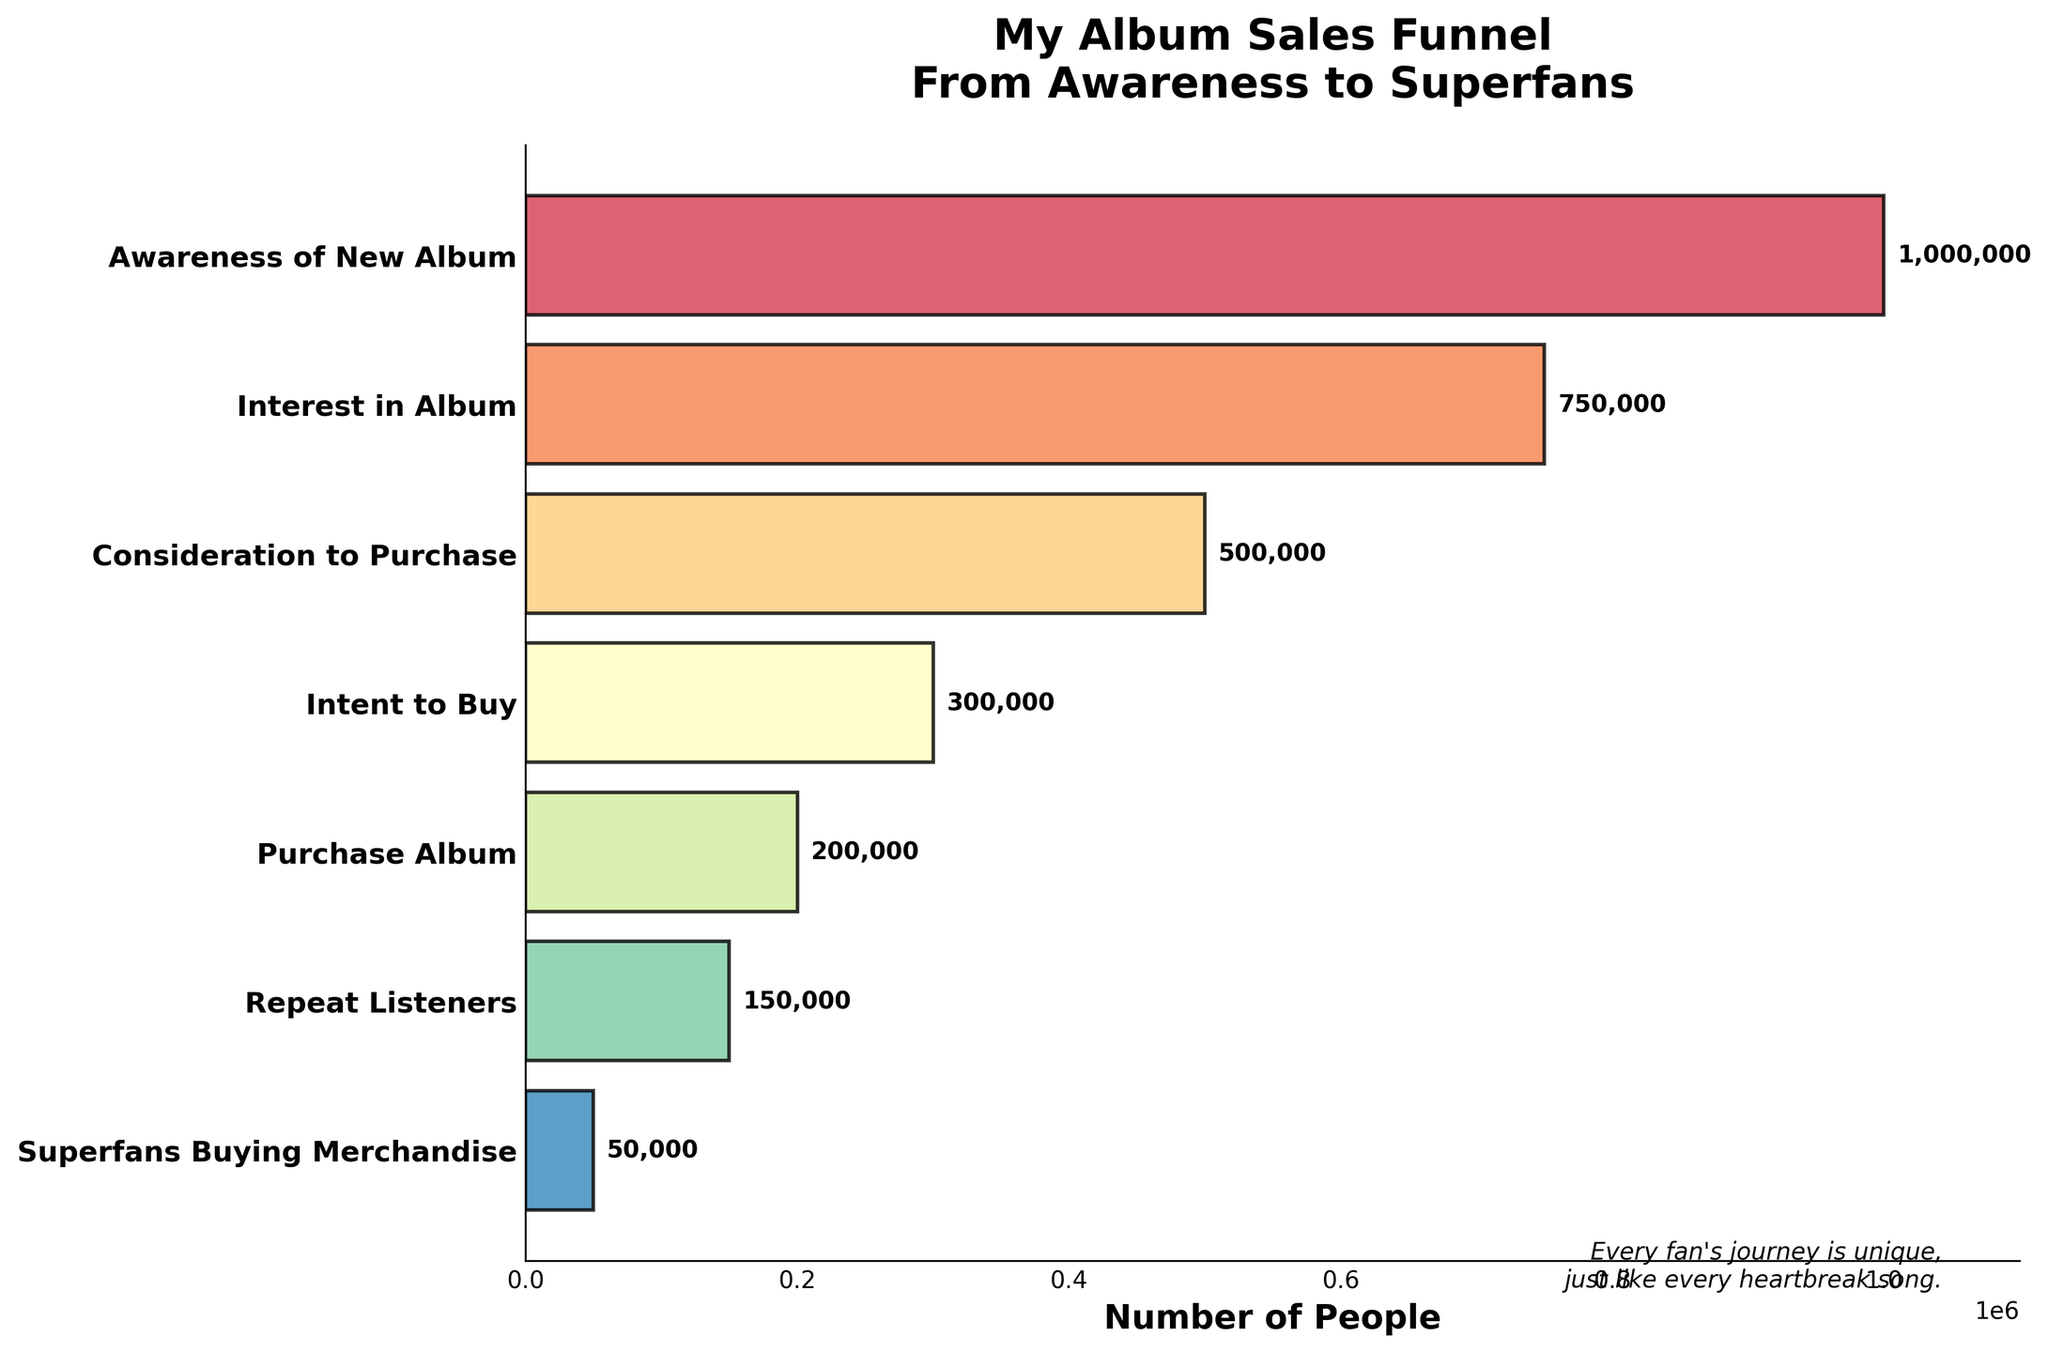How many people are aware of the new album? The number of people at the "Awareness of New Album" stage is listed as the first point in the funnel chart.
Answer: 1,000,000 Which stage has the smallest number of people? The "Superfans Buying Merchandise" stage has the smallest bar on the chart, indicating it has the least number of people.
Answer: Superfans Buying Merchandise What is the difference in the number of people between those who have the intent to buy and those who actually purchase the album? The "Intent to Buy" stage has 300,000 people, and the "Purchase Album" stage has 200,000 people. The difference is calculated as 300,000 - 200,000.
Answer: 100,000 How many stages are there in the album sales funnel? The funnel chart has 7 bars, each representing a different stage.
Answer: 7 stages What is the ratio of repeat listeners to those who purchase the album? The number of repeat listeners is 150,000, and the number of those who purchase the album is 200,000. The ratio is 150,000 / 200,000.
Answer: 0.75 Which stage shows the largest drop in the number of people compared to the previous stage? By comparing each successive pair of stages, the largest drop is from "Consideration to Purchase" (500,000) to "Intent to Buy" (300,000). The difference is 500,000 - 300,000.
Answer: Consideration to Purchase to Intent to Buy What percentage of people who are aware of the new album actually purchase it? There are 1,000,000 people aware of the new album and 200,000 who purchase it. The percentage is calculated as (200,000 / 1,000,000) * 100%.
Answer: 20% What is the sum of people in the stages from 'Interest in Album' to 'Purchase Album'? Summing the values from "Interest in Album" (750,000) to "Purchase Album" (200,000): 750,000 + 500,000 + 300,000 + 200,000.
Answer: 1,750,000 Is the number of people at the interest stage greater than twice the number of people at the repeat listeners stage? The number of people at the interest stage is 750,000, and at the repeat listeners stage it is 150,000. Twice the number of repeat listeners is 150,000 * 2 = 300,000. Since 750,000 > 300,000, the answer is yes.
Answer: Yes 